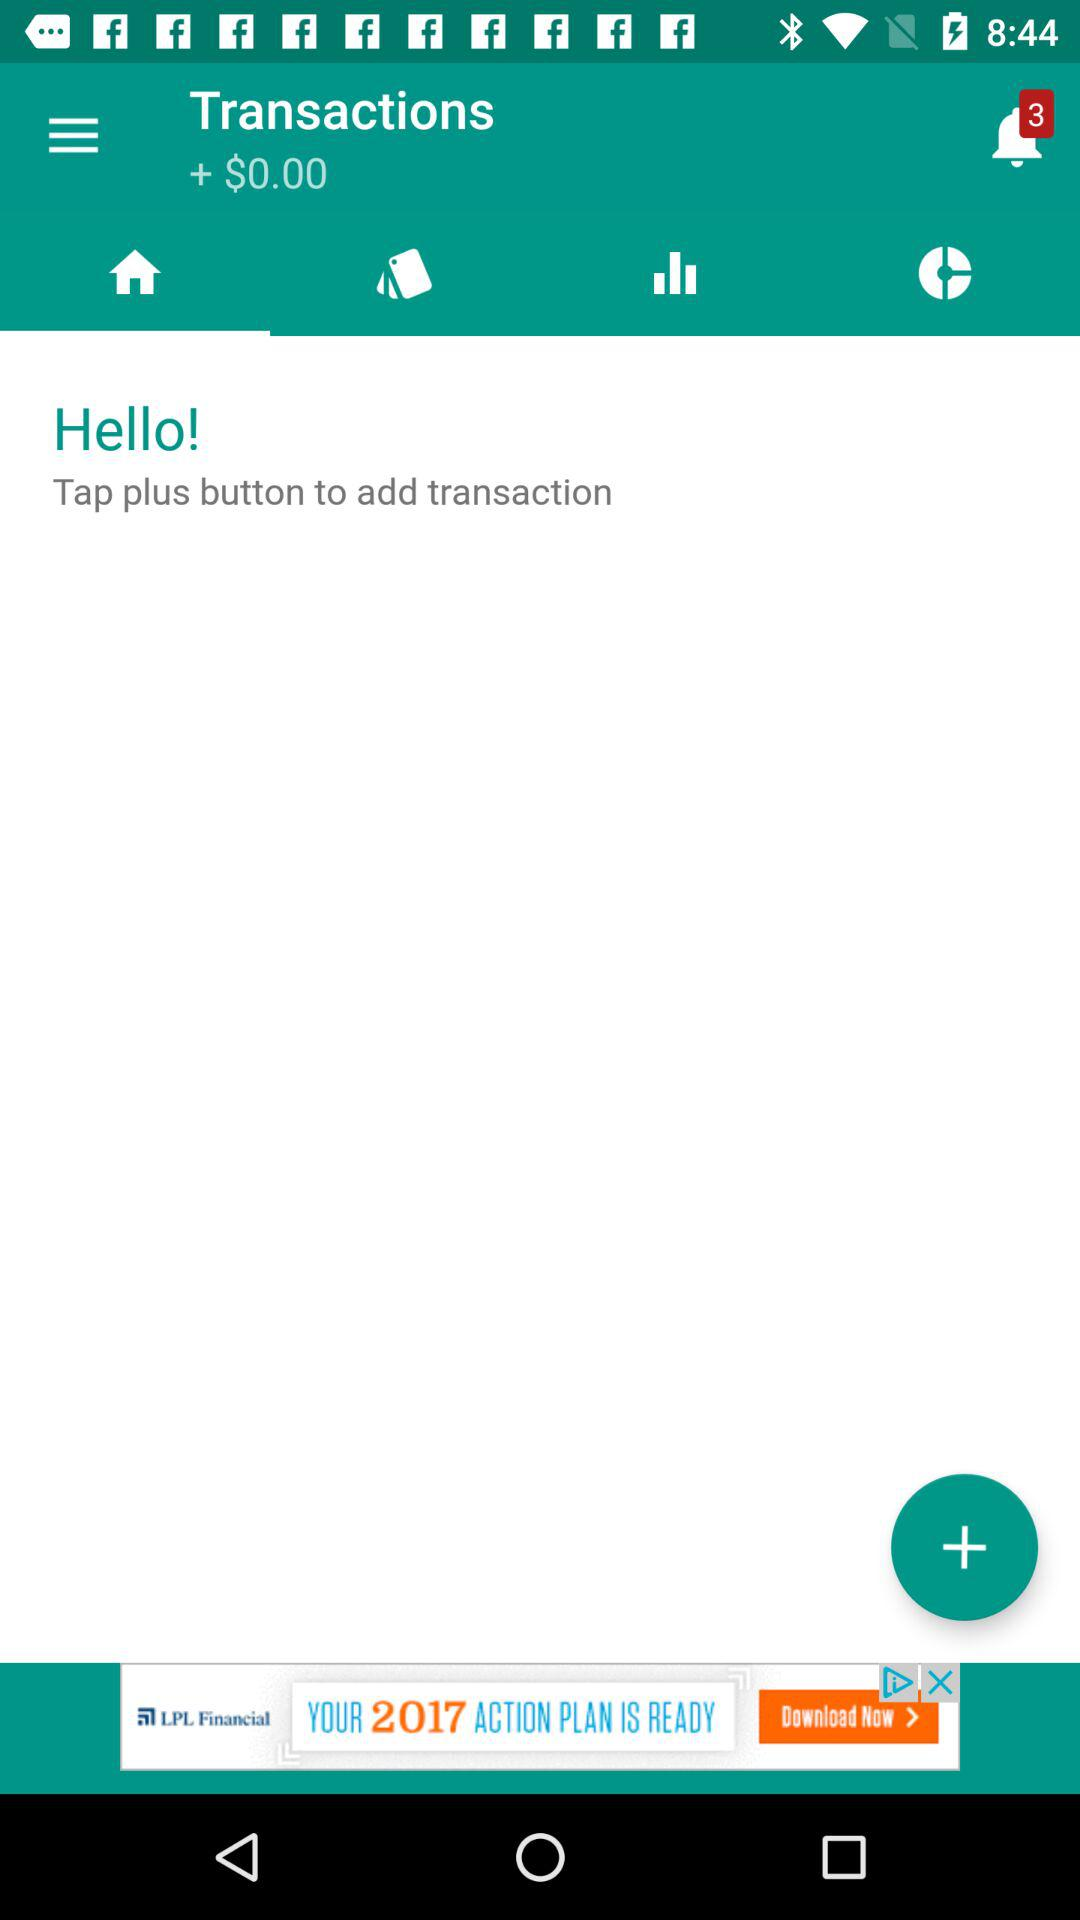How many points are available in transactions? The available points are "+$0.00". 